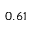Convert formula to latex. <formula><loc_0><loc_0><loc_500><loc_500>0 . 6 1</formula> 